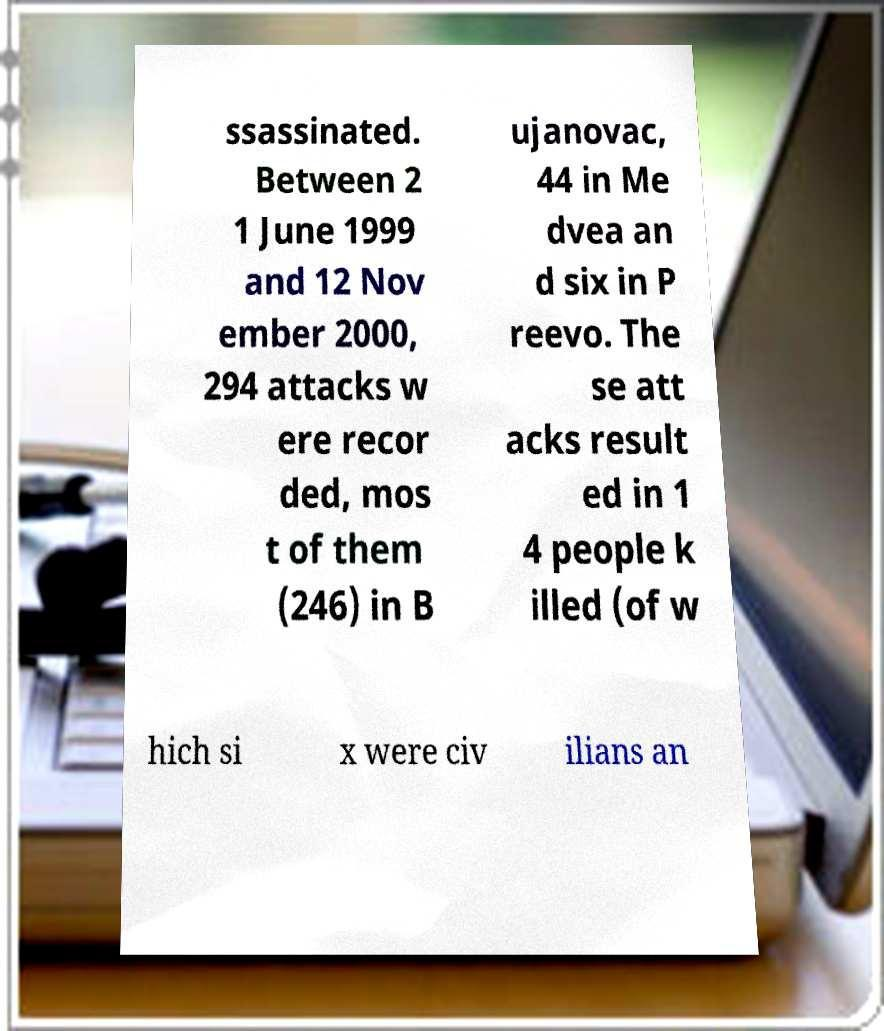Can you accurately transcribe the text from the provided image for me? ssassinated. Between 2 1 June 1999 and 12 Nov ember 2000, 294 attacks w ere recor ded, mos t of them (246) in B ujanovac, 44 in Me dvea an d six in P reevo. The se att acks result ed in 1 4 people k illed (of w hich si x were civ ilians an 